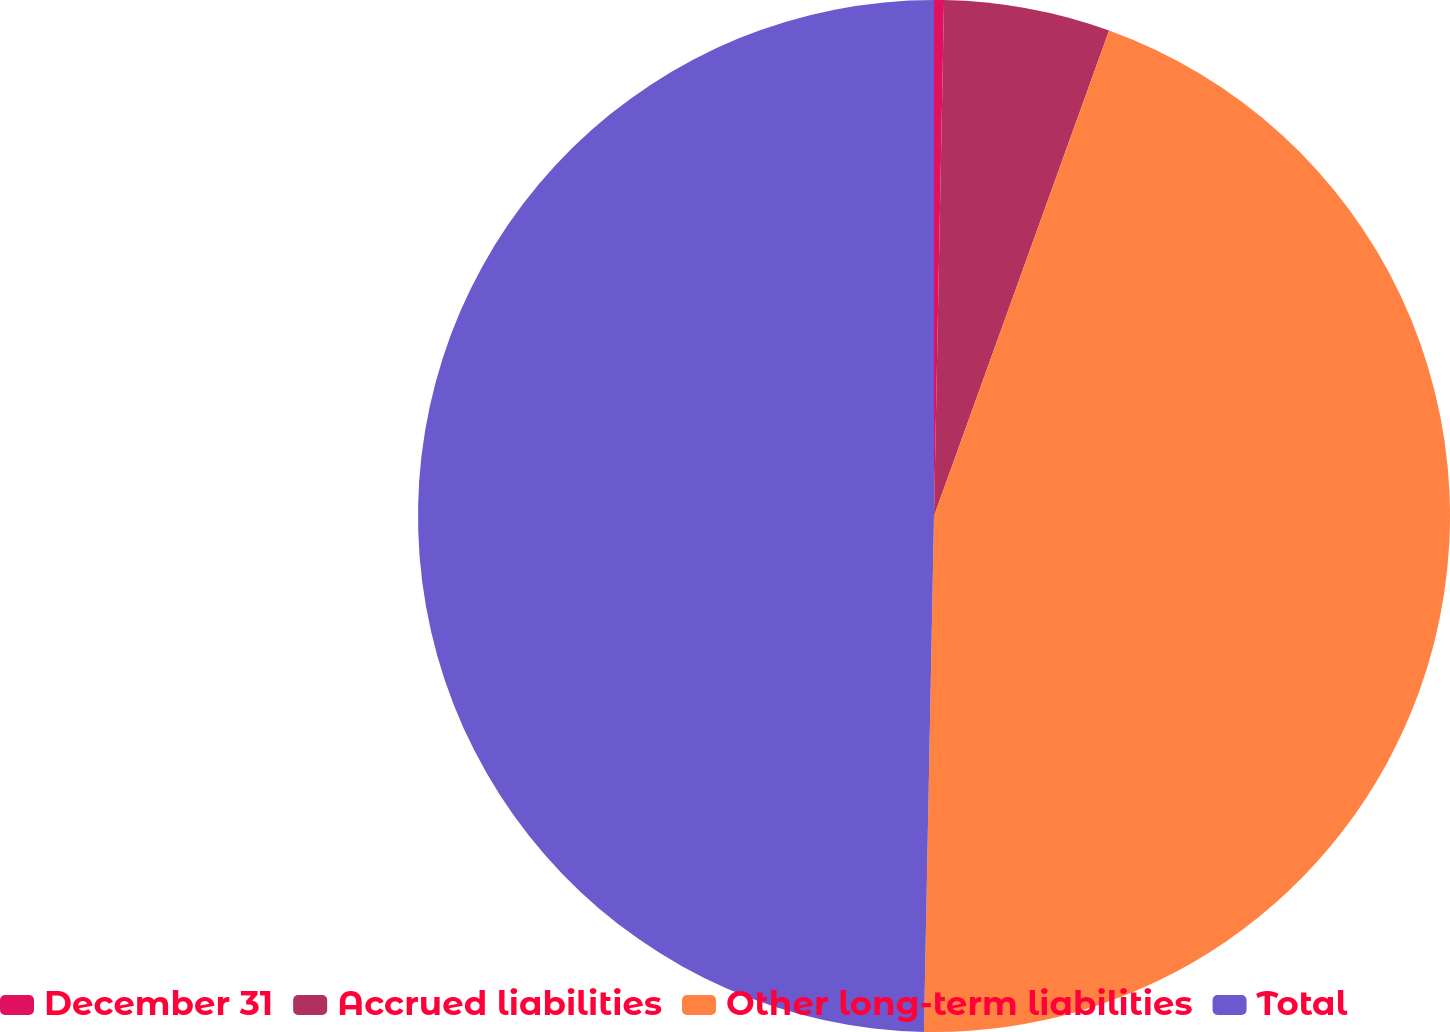Convert chart. <chart><loc_0><loc_0><loc_500><loc_500><pie_chart><fcel>December 31<fcel>Accrued liabilities<fcel>Other long-term liabilities<fcel>Total<nl><fcel>0.31%<fcel>5.2%<fcel>44.8%<fcel>49.69%<nl></chart> 